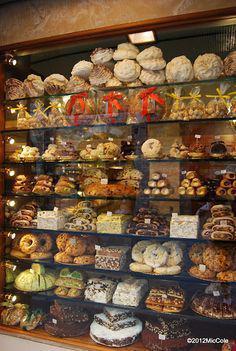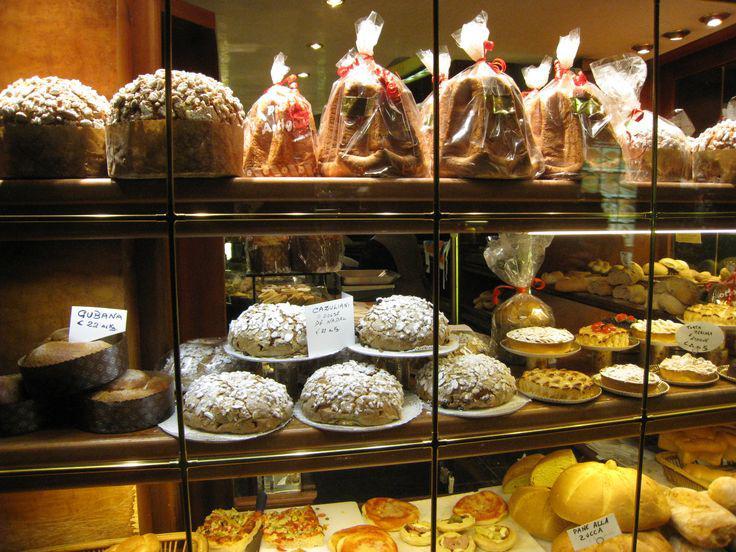The first image is the image on the left, the second image is the image on the right. Considering the images on both sides, is "At least one person is in one image behind a filled bakery display case with three or more shelves and a glass front" valid? Answer yes or no. No. 